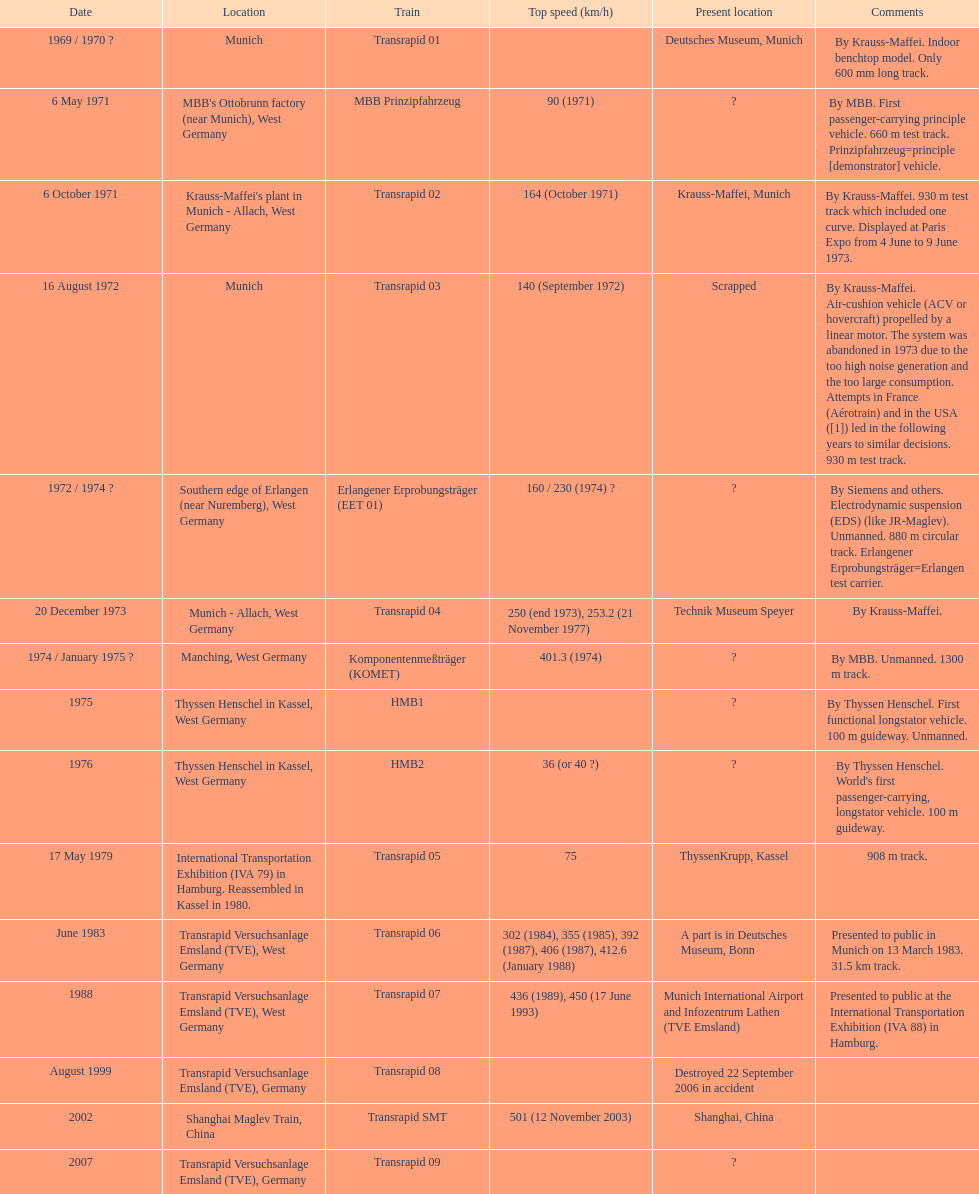Would you be able to parse every entry in this table? {'header': ['Date', 'Location', 'Train', 'Top speed (km/h)', 'Present location', 'Comments'], 'rows': [['1969 / 1970\xa0?', 'Munich', 'Transrapid 01', '', 'Deutsches Museum, Munich', 'By Krauss-Maffei. Indoor benchtop model. Only 600\xa0mm long track.'], ['6 May 1971', "MBB's Ottobrunn factory (near Munich), West Germany", 'MBB Prinzipfahrzeug', '90 (1971)', '?', 'By MBB. First passenger-carrying principle vehicle. 660 m test track. Prinzipfahrzeug=principle [demonstrator] vehicle.'], ['6 October 1971', "Krauss-Maffei's plant in Munich - Allach, West Germany", 'Transrapid 02', '164 (October 1971)', 'Krauss-Maffei, Munich', 'By Krauss-Maffei. 930 m test track which included one curve. Displayed at Paris Expo from 4 June to 9 June 1973.'], ['16 August 1972', 'Munich', 'Transrapid 03', '140 (September 1972)', 'Scrapped', 'By Krauss-Maffei. Air-cushion vehicle (ACV or hovercraft) propelled by a linear motor. The system was abandoned in 1973 due to the too high noise generation and the too large consumption. Attempts in France (Aérotrain) and in the USA ([1]) led in the following years to similar decisions. 930 m test track.'], ['1972 / 1974\xa0?', 'Southern edge of Erlangen (near Nuremberg), West Germany', 'Erlangener Erprobungsträger (EET 01)', '160 / 230 (1974)\xa0?', '?', 'By Siemens and others. Electrodynamic suspension (EDS) (like JR-Maglev). Unmanned. 880 m circular track. Erlangener Erprobungsträger=Erlangen test carrier.'], ['20 December 1973', 'Munich - Allach, West Germany', 'Transrapid 04', '250 (end 1973), 253.2 (21 November 1977)', 'Technik Museum Speyer', 'By Krauss-Maffei.'], ['1974 / January 1975\xa0?', 'Manching, West Germany', 'Komponentenmeßträger (KOMET)', '401.3 (1974)', '?', 'By MBB. Unmanned. 1300 m track.'], ['1975', 'Thyssen Henschel in Kassel, West Germany', 'HMB1', '', '?', 'By Thyssen Henschel. First functional longstator vehicle. 100 m guideway. Unmanned.'], ['1976', 'Thyssen Henschel in Kassel, West Germany', 'HMB2', '36 (or 40\xa0?)', '?', "By Thyssen Henschel. World's first passenger-carrying, longstator vehicle. 100 m guideway."], ['17 May 1979', 'International Transportation Exhibition (IVA 79) in Hamburg. Reassembled in Kassel in 1980.', 'Transrapid 05', '75', 'ThyssenKrupp, Kassel', '908 m track.'], ['June 1983', 'Transrapid Versuchsanlage Emsland (TVE), West Germany', 'Transrapid 06', '302 (1984), 355 (1985), 392 (1987), 406 (1987), 412.6 (January 1988)', 'A part is in Deutsches Museum, Bonn', 'Presented to public in Munich on 13 March 1983. 31.5\xa0km track.'], ['1988', 'Transrapid Versuchsanlage Emsland (TVE), West Germany', 'Transrapid 07', '436 (1989), 450 (17 June 1993)', 'Munich International Airport and Infozentrum Lathen (TVE Emsland)', 'Presented to public at the International Transportation Exhibition (IVA 88) in Hamburg.'], ['August 1999', 'Transrapid Versuchsanlage Emsland (TVE), Germany', 'Transrapid 08', '', 'Destroyed 22 September 2006 in accident', ''], ['2002', 'Shanghai Maglev Train, China', 'Transrapid SMT', '501 (12 November 2003)', 'Shanghai, China', ''], ['2007', 'Transrapid Versuchsanlage Emsland (TVE), Germany', 'Transrapid 09', '', '?', '']]} What is the number of trains that were either scrapped or destroyed? 2. 